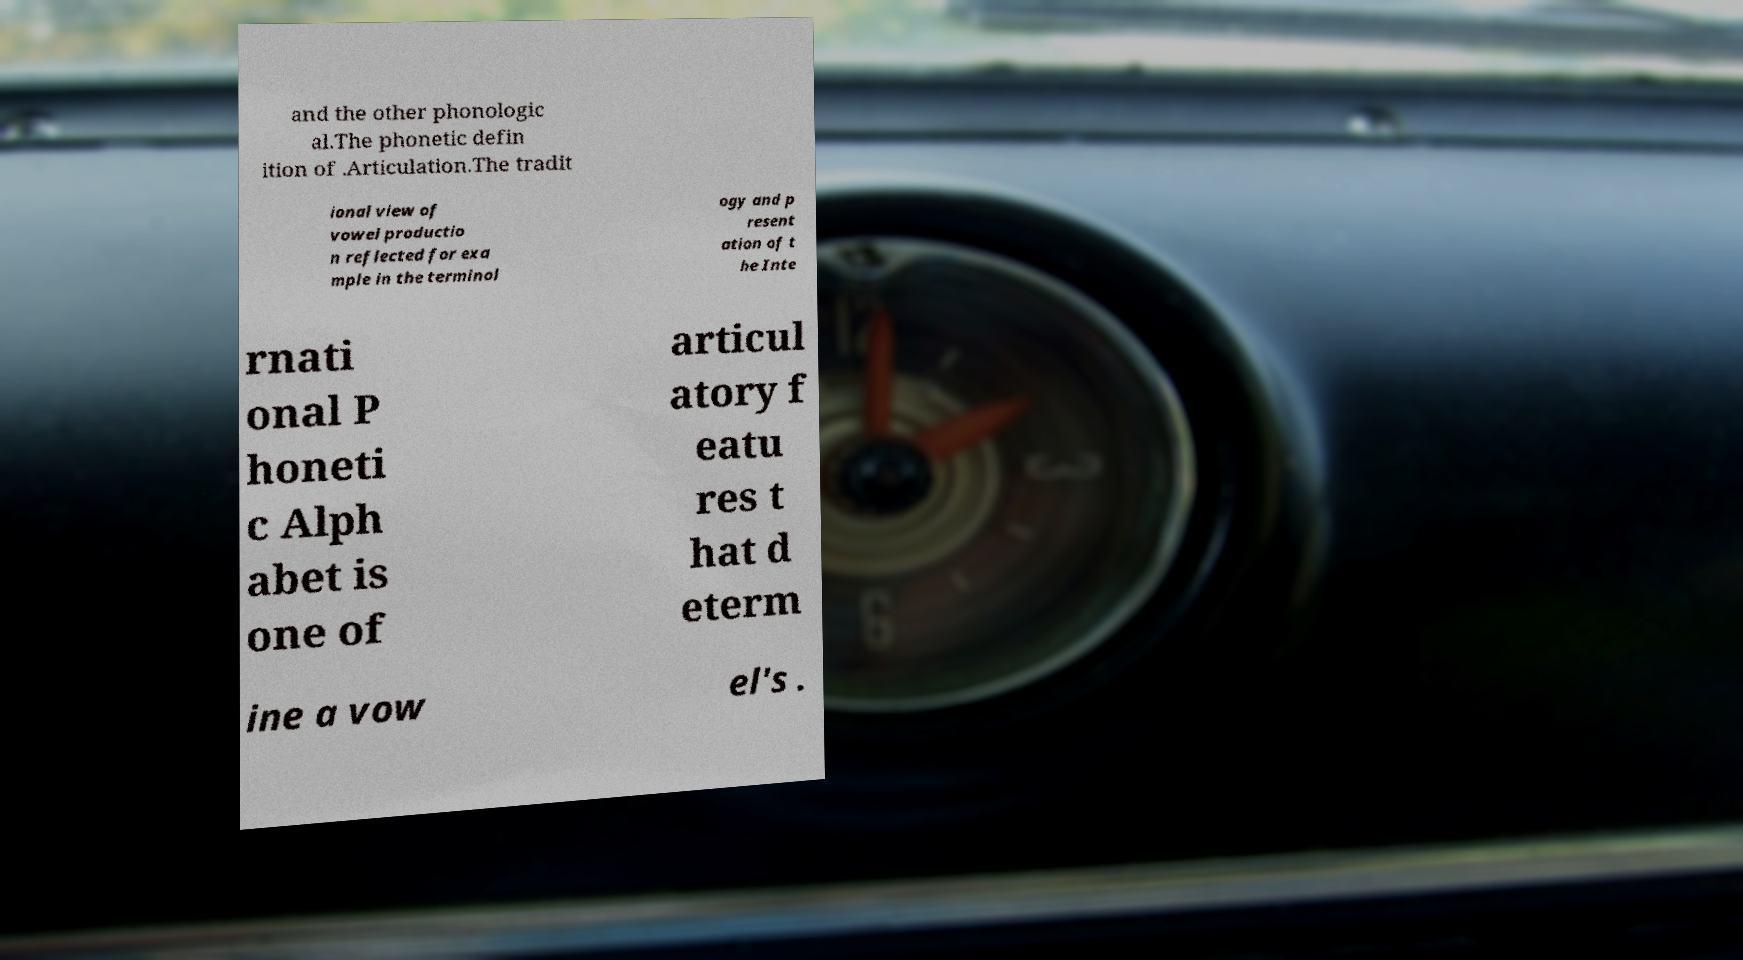Can you accurately transcribe the text from the provided image for me? and the other phonologic al.The phonetic defin ition of .Articulation.The tradit ional view of vowel productio n reflected for exa mple in the terminol ogy and p resent ation of t he Inte rnati onal P honeti c Alph abet is one of articul atory f eatu res t hat d eterm ine a vow el's . 